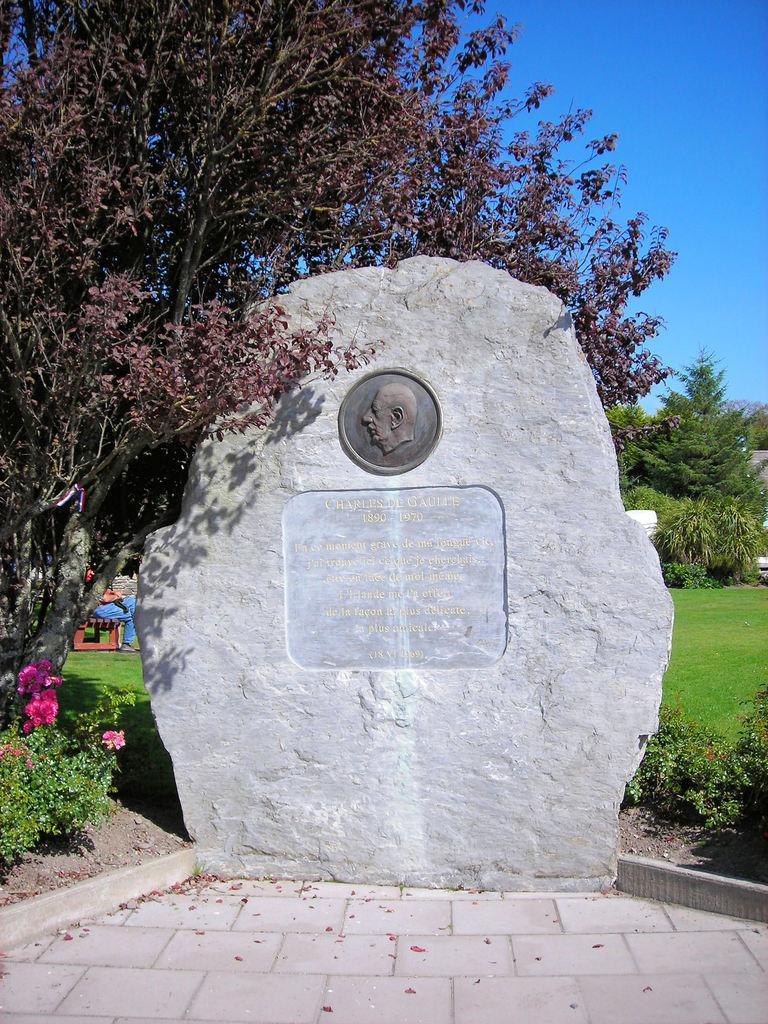What is the main structure in the image? There is a Stonehenge in the image. What can be seen on the ground around the Stonehenge? There are plants and grass on the ground. What is visible in the background of the image? There are trees and the sky in the background of the image. What type of iron is used to create the night yard in the image? There is no night yard or iron present in the image. The image features Stonehenge, plants, grass, trees, and the sky. 